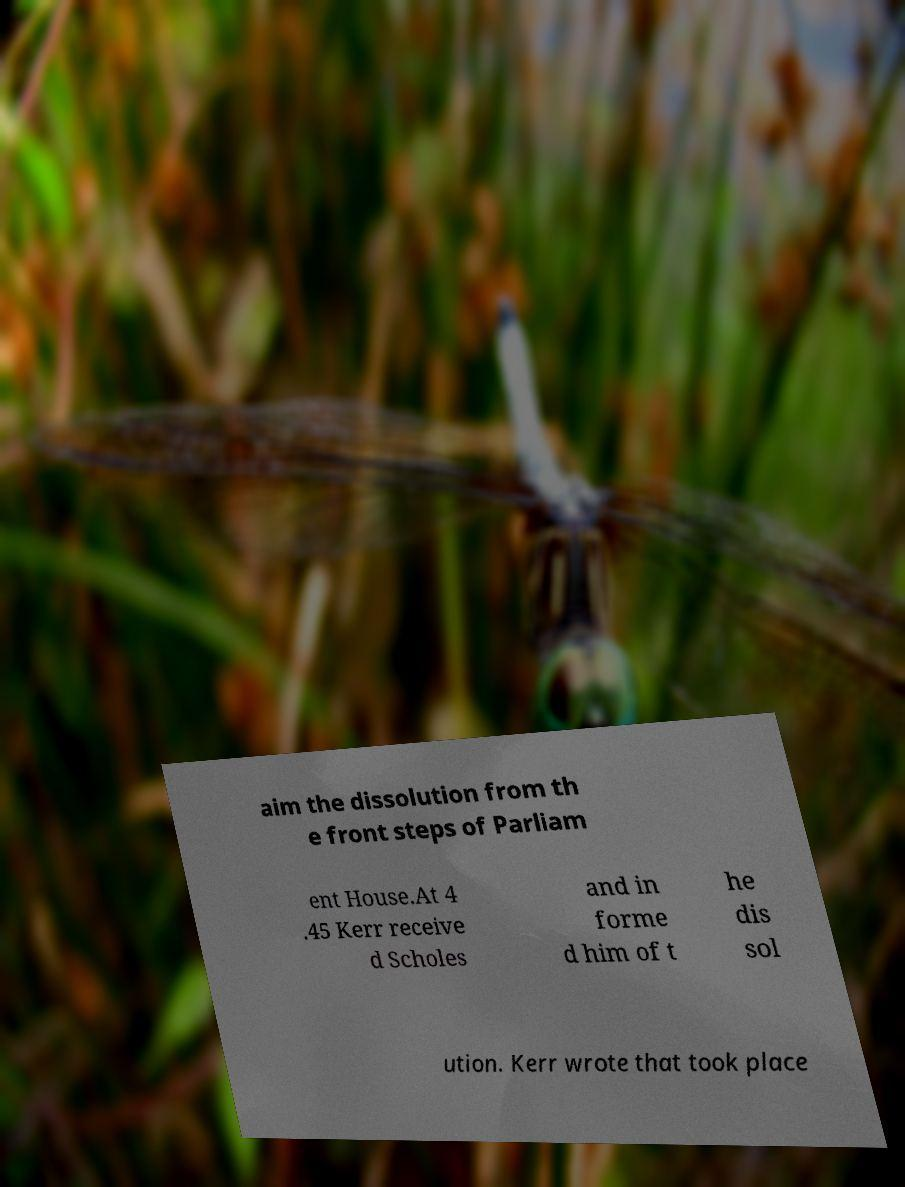Please identify and transcribe the text found in this image. aim the dissolution from th e front steps of Parliam ent House.At 4 .45 Kerr receive d Scholes and in forme d him of t he dis sol ution. Kerr wrote that took place 